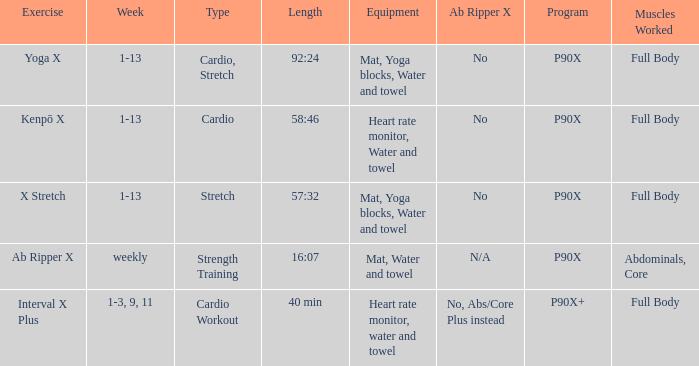What is the ab ripper x when exercise is x stretch? No. 